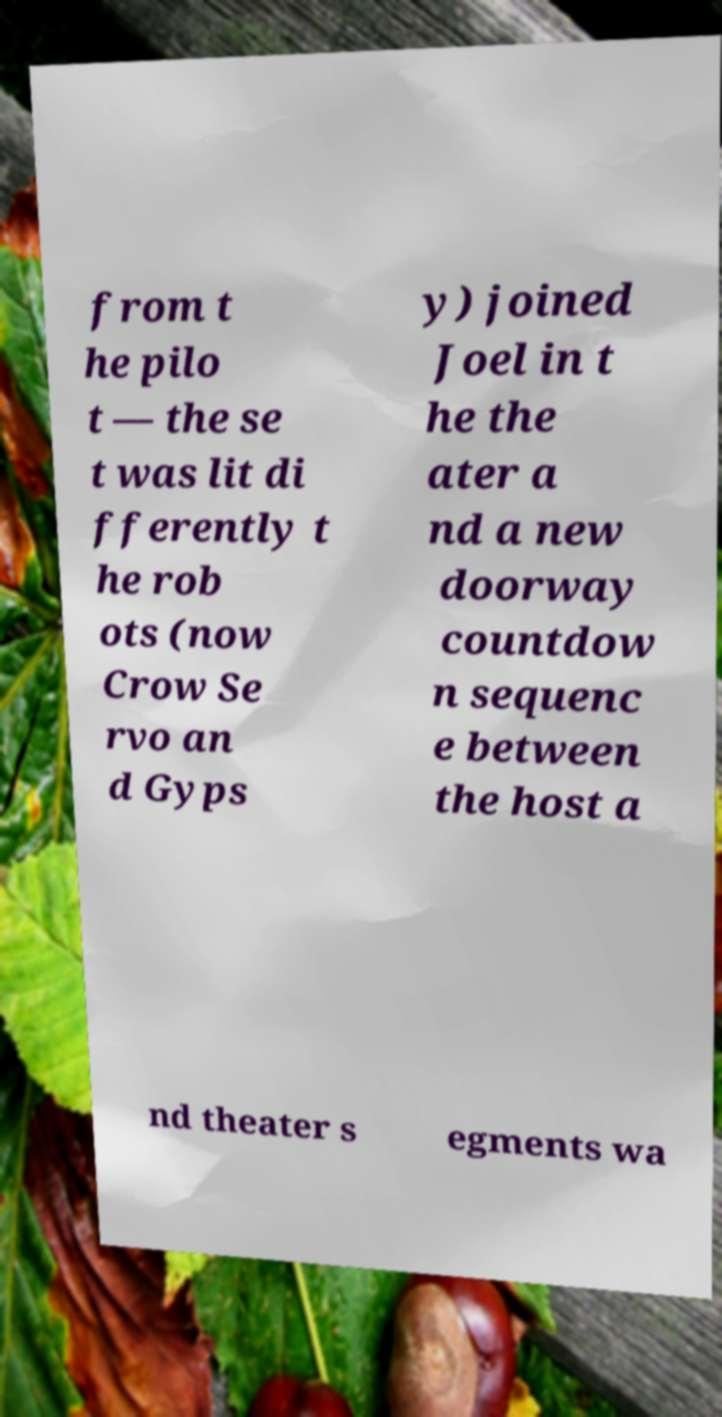What messages or text are displayed in this image? I need them in a readable, typed format. from t he pilo t — the se t was lit di fferently t he rob ots (now Crow Se rvo an d Gyps y) joined Joel in t he the ater a nd a new doorway countdow n sequenc e between the host a nd theater s egments wa 